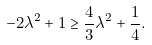<formula> <loc_0><loc_0><loc_500><loc_500>- 2 \lambda ^ { 2 } + 1 \geq \frac { 4 } { 3 } \lambda ^ { 2 } + \frac { 1 } { 4 } .</formula> 